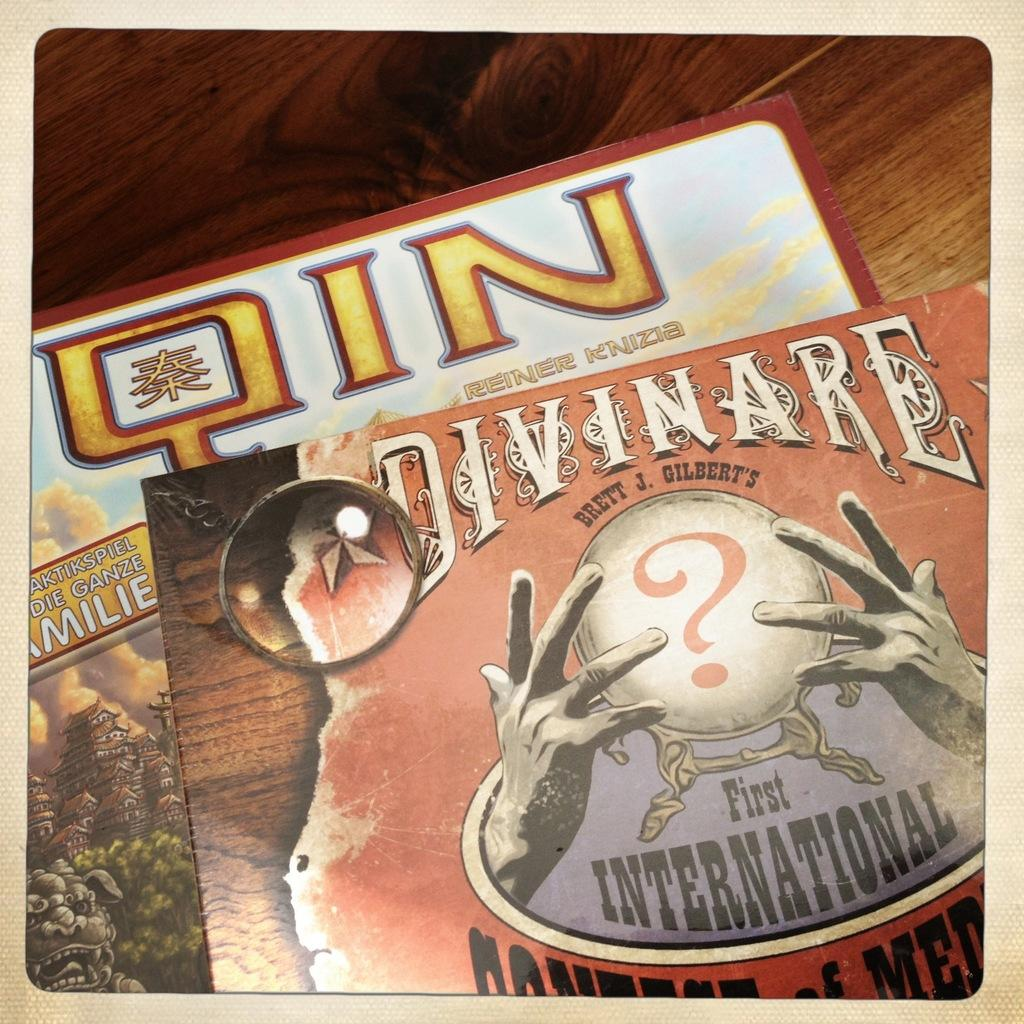<image>
Render a clear and concise summary of the photo. Cover for Divineare on top of abook titled "QIN". 